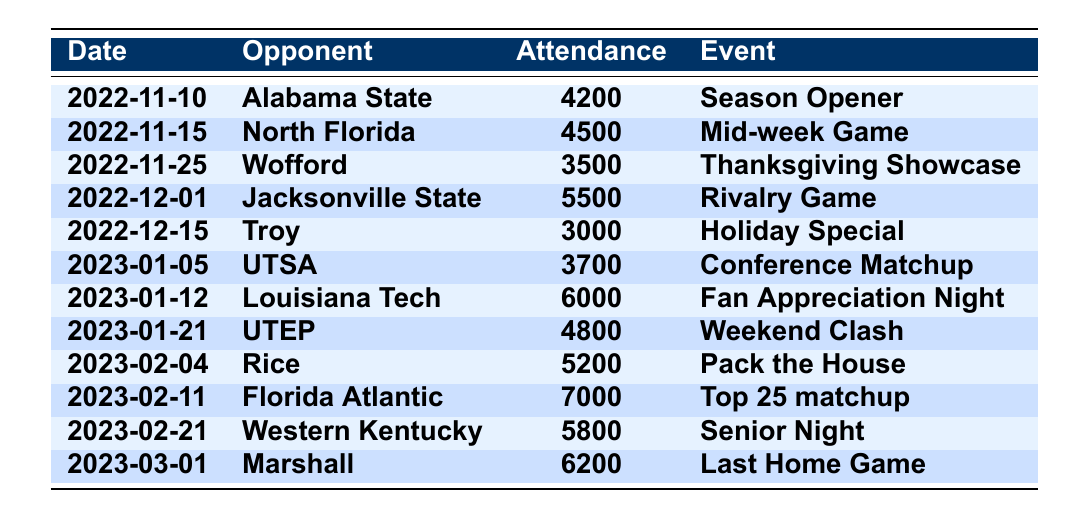What was the attendance for the game against Florida Atlantic? The table indicates that the attendance for the game against Florida Atlantic on February 11, 2023, was 7000.
Answer: 7000 Which game had the lowest attendance? By examining the attendance figures, the game against Troy on December 15, 2022, had the lowest attendance of 3000.
Answer: 3000 What is the total attendance for all home games listed? Summing the attendance figures from each game: 4200 + 4500 + 3500 + 5500 + 3000 + 3700 + 6000 + 4800 + 5200 + 7000 + 5800 + 6200 =  65,400.
Answer: 65400 Did UAB win all the games with an attendance of over 6000? The games with attendance over 6000 were against Louisiana Tech (6000), Florida Atlantic (7000), and Marshall (6200). All these games were noted as significant events, implying possible high performance, but the results are not provided in the table, so the answer is uncertain.
Answer: No How many games had an attendance figure greater than 5000? The games with attendance greater than 5000 are Louisiana Tech (6000), Florida Atlantic (7000), Marshall (6200), and Jacksonville State (5500), totaling four games.
Answer: 4 What was the average attendance for the season? The total attendance from all games is 65,400, and there are 12 games. The average attendance is therefore 65,400 / 12 ≈ 5450.
Answer: 5450 What event was associated with the highest attendance? The table indicates that the event associated with the highest attendance of 7000 was the game against Florida Atlantic on February 11, 2023, labeled as a "Top 25 matchup."
Answer: Top 25 matchup Was the attendance for the last game higher or lower than the attendance for the season opener? The attendance for the last game against Marshall was 6200, while the attendance for the season opener against Alabama State was 4200. Therefore, the last game had higher attendance than the season opener.
Answer: Higher What is the difference in attendance between the game against Western Kentucky and the game against Wofford? The attendance for Western Kentucky is 5800 and for Wofford is 3500. The difference can be calculated as 5800 - 3500 = 2300.
Answer: 2300 Which opponent had the closest attendance figure to 5000? The attendance figures closest to 5000 are UTEP (4800) and Rice (5200). Both are just 200 away from 5000. Since 5200 is higher, that opponent is Rice.
Answer: Rice 